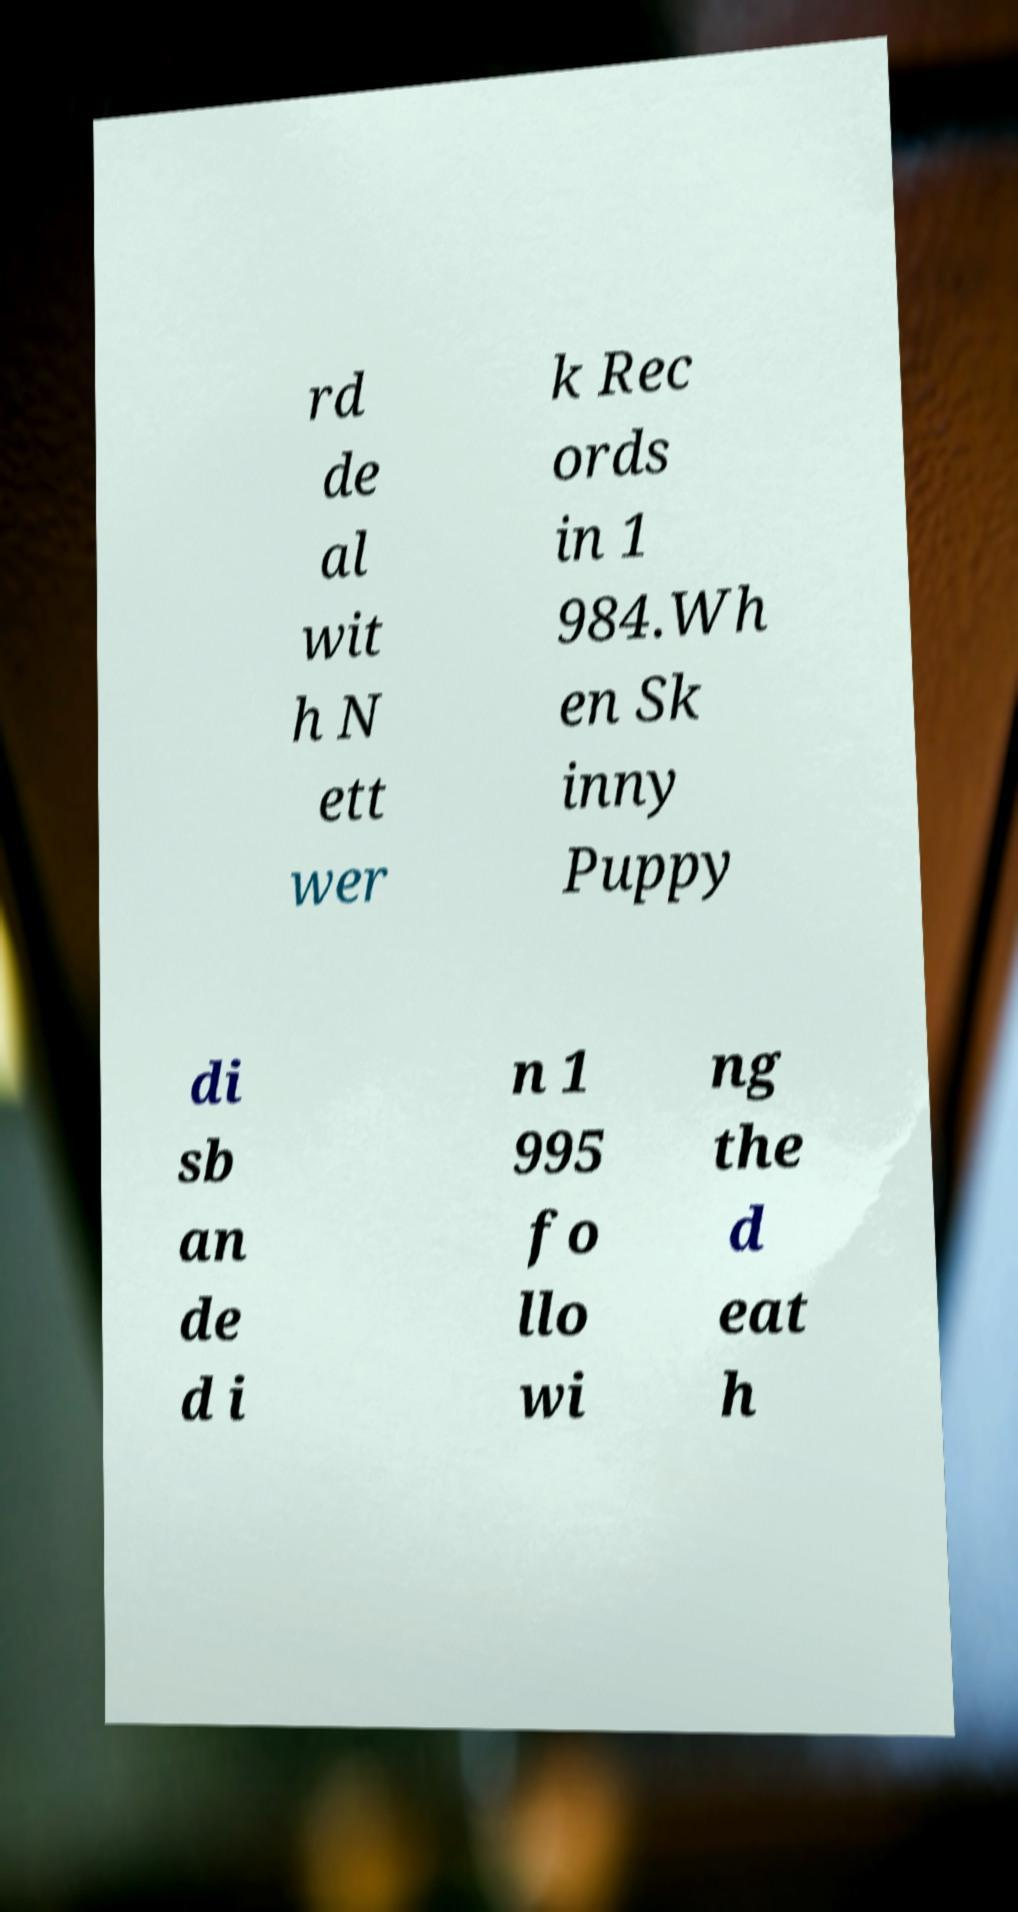There's text embedded in this image that I need extracted. Can you transcribe it verbatim? rd de al wit h N ett wer k Rec ords in 1 984.Wh en Sk inny Puppy di sb an de d i n 1 995 fo llo wi ng the d eat h 